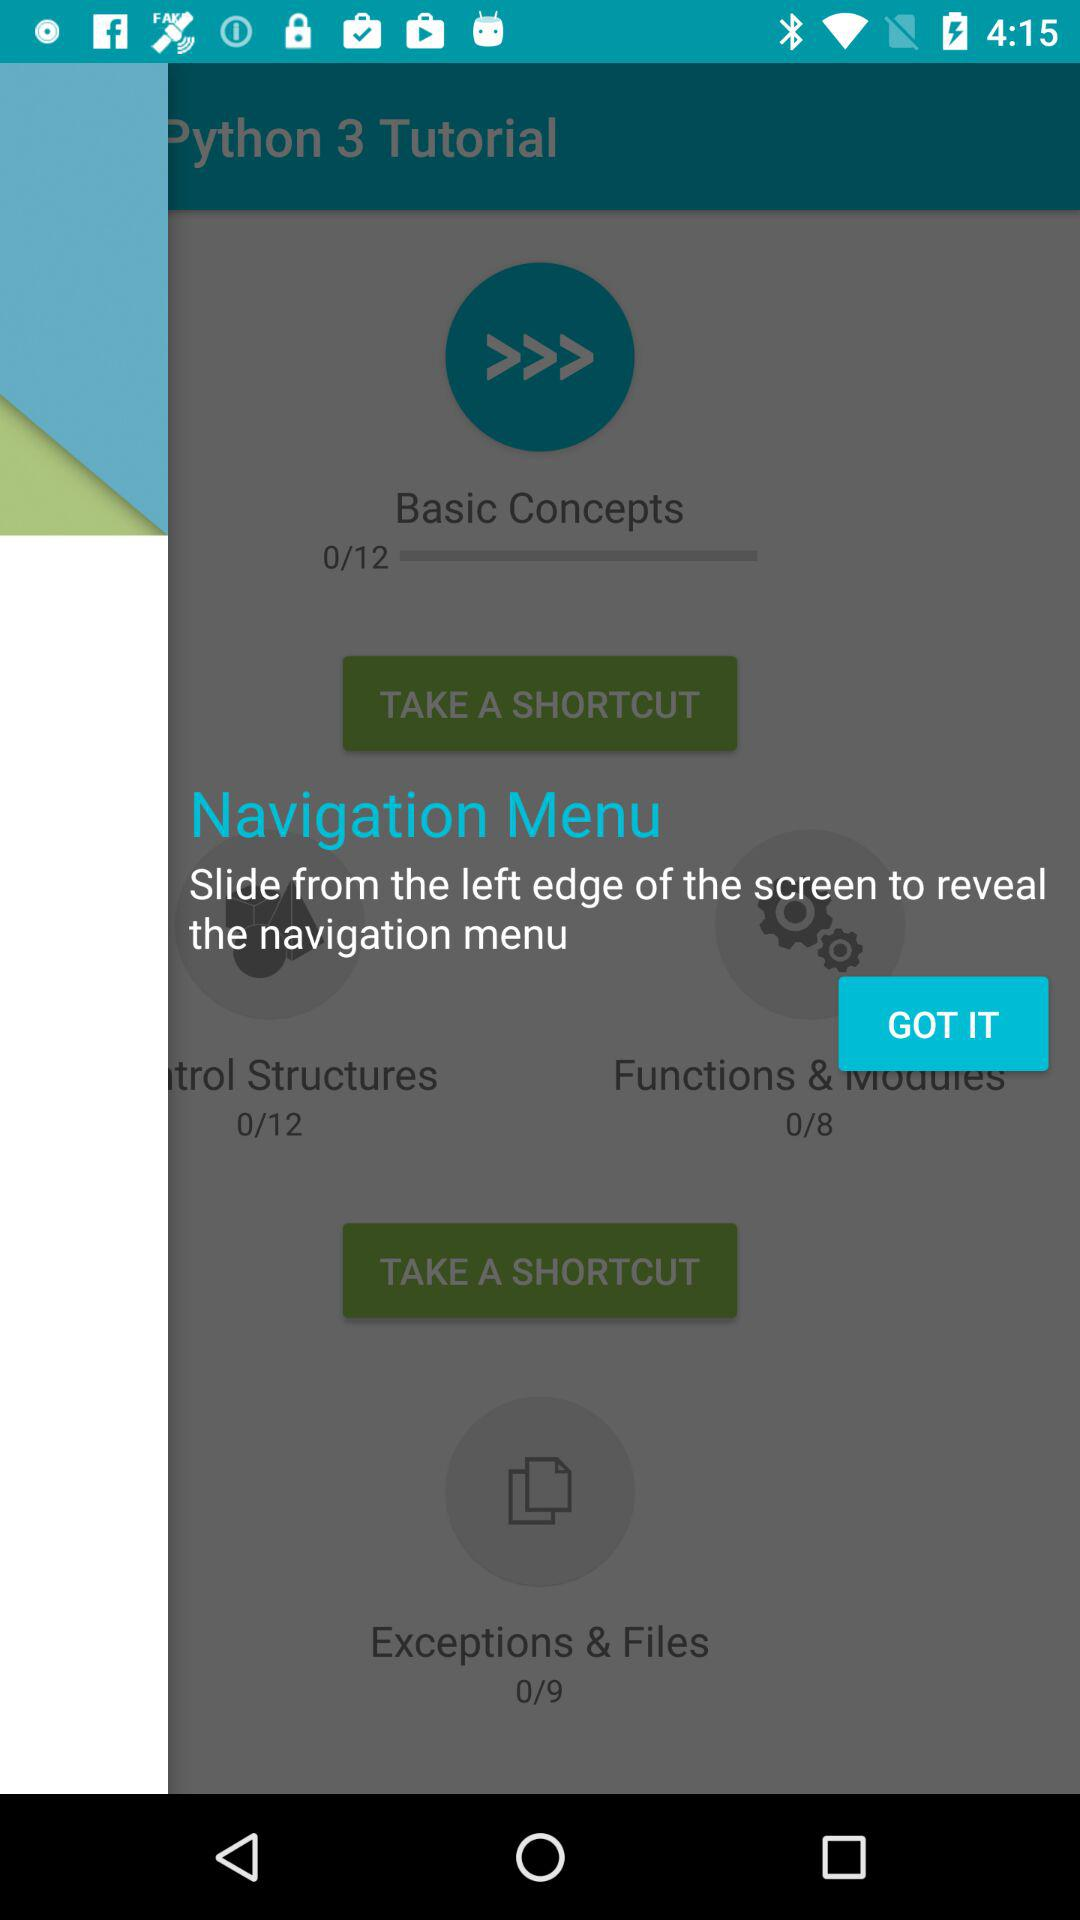What is the total number of slides in "Functions and Modules"? The total number of slides in "Functions and Modules" is 8. 